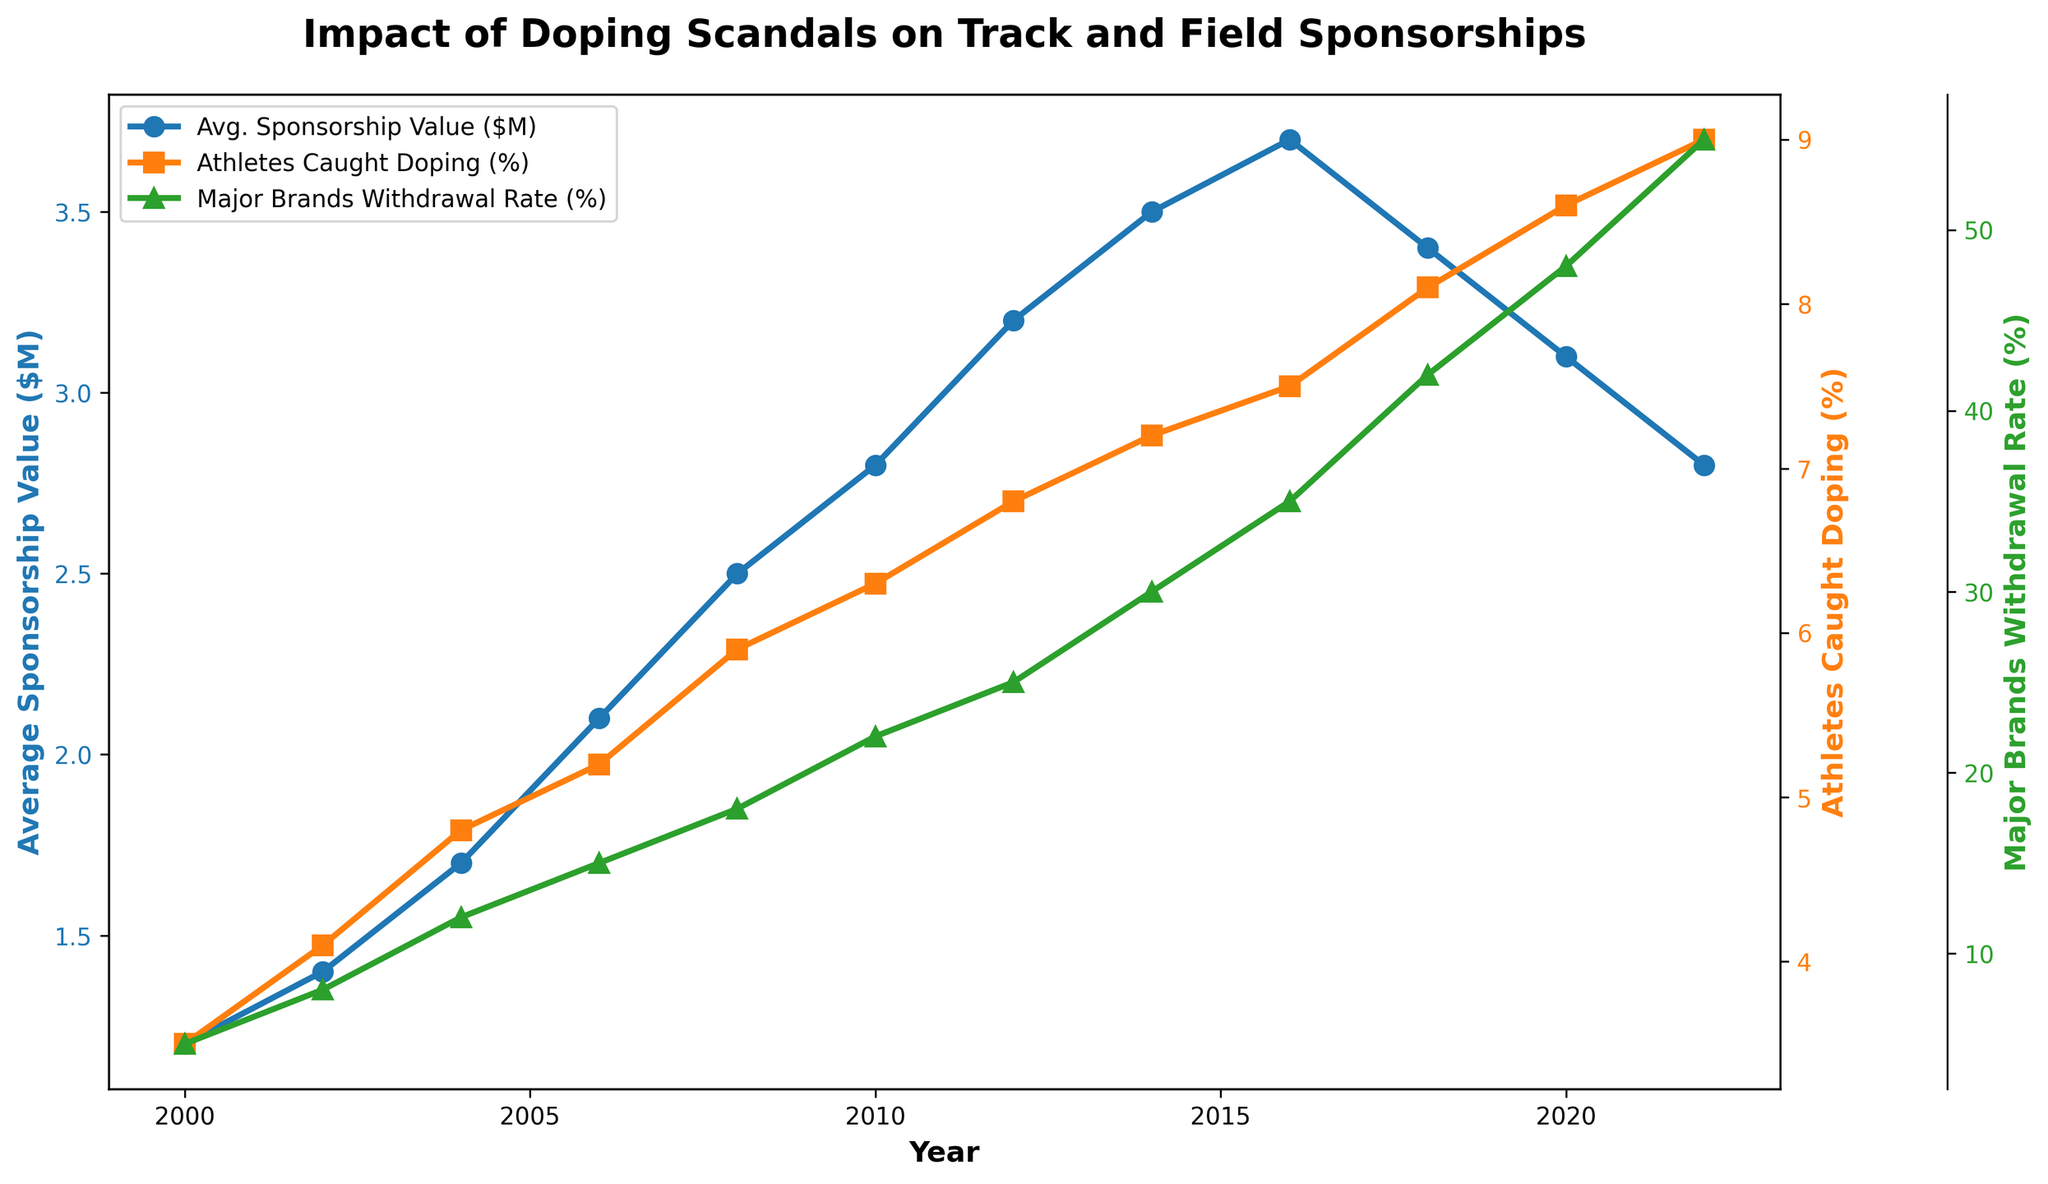What is the trend in the Average Sponsorship Value from 2000 to 2022? The Average Sponsorship Value ($M) generally increases from 2000 ($1.2M) to a peak in 2016 ($3.7M), then starts decreasing again to $2.8M in 2022.
Answer: Increasing until 2016, then decreasing How has the percentage of Athletes Caught Doping changed from 2000 to 2022? The percentage of Athletes Caught Doping (%) shows a steady increase from 3.5% in 2000 to 9.0% in 2022.
Answer: Steady increase Compare the trend in Major Brands Withdrawal Rate with the trend in Average Sponsorship Value. The Major Brands Withdrawal Rate (%) increases steadily from 5% in 2000 to 55% in 2022. In contrast, the Average Sponsorship Value increases until 2016 and then starts to decline.
Answer: Major Brands Withdrawal Rate increases; Average Sponsorship Value initially increases then decreases At what year did the Average Sponsorship Value peak, and what was its value? The Average Sponsorship Value peaks in 2016 with a value of $3.7M.
Answer: 2016, $3.7M What is the relationship between the percentage of Athletes Caught Doping and Major Brands Withdrawal Rate over time? Both the percentage of Athletes Caught Doping and the Major Brands Withdrawal Rate generally increase over time, suggesting a correlation between these variables.
Answer: Both increasing How does the Average Sponsorship Value in 2022 compare to that in 2008? The Average Sponsorship Value in 2022 ($2.8M) is slightly higher than in 2008 ($2.5M), despite a peak in 2016.
Answer: Slightly higher What visual attribute makes it easy to identify the trends of three different metrics on the figure? The use of different colors (blue for Average Sponsorship Value, orange for Athletes Caught Doping, and green for Major Brands Withdrawal Rate) and unique markers (circles, squares, triangles) makes it easy to distinguish the trends.
Answer: Color and marker differentiation What is the change in the Major Brands Withdrawal Rate from 2000 to 2022? The Major Brands Withdrawal Rate increases from 5% in 2000 to 55% in 2022. The change equals 55% - 5% = 50%.
Answer: 50% Which metric has shown the most drastic change over the period 2000 to 2022? The Major Brands Withdrawal Rate has shown the most drastic change, increasing by 50% from 5% to 55% from 2000 to 2022.
Answer: Major Brands Withdrawal Rate If you look at the year 2010, what can you infer about all three metrics? In 2010, the Average Sponsorship Value was $2.8M, the percentage of Athletes Caught Doping was 6.3%, and the Major Brands Withdrawal Rate was 22%. This indicates an upward trend in all three metrics continuing to develop during that year.
Answer: Increasing trends in all metrics 